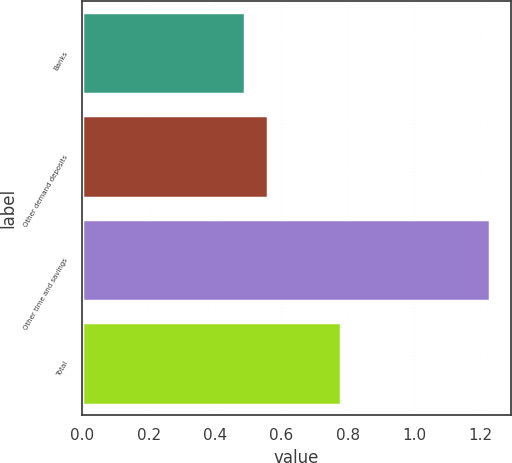Convert chart. <chart><loc_0><loc_0><loc_500><loc_500><bar_chart><fcel>Banks<fcel>Other demand deposits<fcel>Other time and savings<fcel>Total<nl><fcel>0.49<fcel>0.56<fcel>1.23<fcel>0.78<nl></chart> 